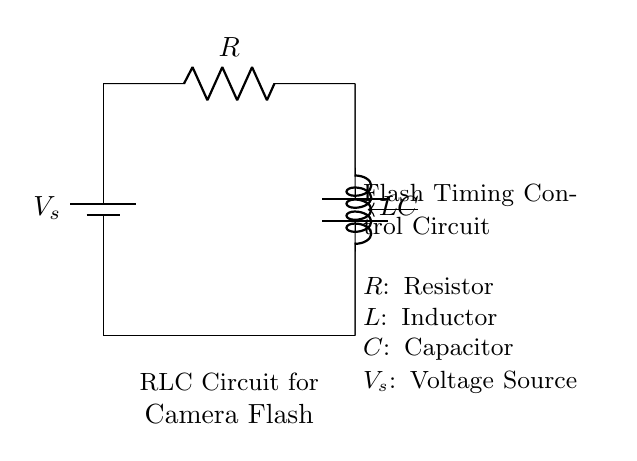What are the components in this circuit? The circuit contains a resistor, inductor, capacitor, and a voltage source as indicated by their respective symbols.
Answer: Resistor, Inductor, Capacitor, Voltage Source What is the role of the inductor in this circuit? The inductor stores energy in a magnetic field when current flows through it, which is essential for timing control in the flash circuit.
Answer: Stores energy How is the capacitor connected in the circuit? The capacitor is connected in parallel with the inductor to allow for charging and discharging during the flash timing process.
Answer: In parallel What is the purpose of the resistor in this circuit? The resistor limits the flow of current in the circuit, helping to control the charging and discharging rates of the capacitor and inductor.
Answer: Limits current What happens if the resistance is increased? Increasing the resistance would slow down the charging and discharging cycles in the circuit, resulting in a longer flash duration.
Answer: Longer flash duration What is the significance of the voltage source in the timing control? The voltage source provides the necessary electrical energy to the circuit, powering the flash and influencing the overall behavior of the RLC components.
Answer: Provides energy 